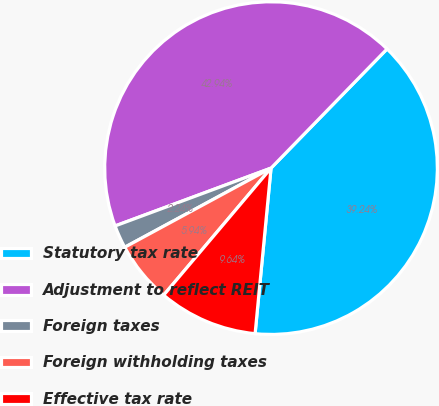Convert chart. <chart><loc_0><loc_0><loc_500><loc_500><pie_chart><fcel>Statutory tax rate<fcel>Adjustment to reflect REIT<fcel>Foreign taxes<fcel>Foreign withholding taxes<fcel>Effective tax rate<nl><fcel>39.24%<fcel>42.94%<fcel>2.24%<fcel>5.94%<fcel>9.64%<nl></chart> 